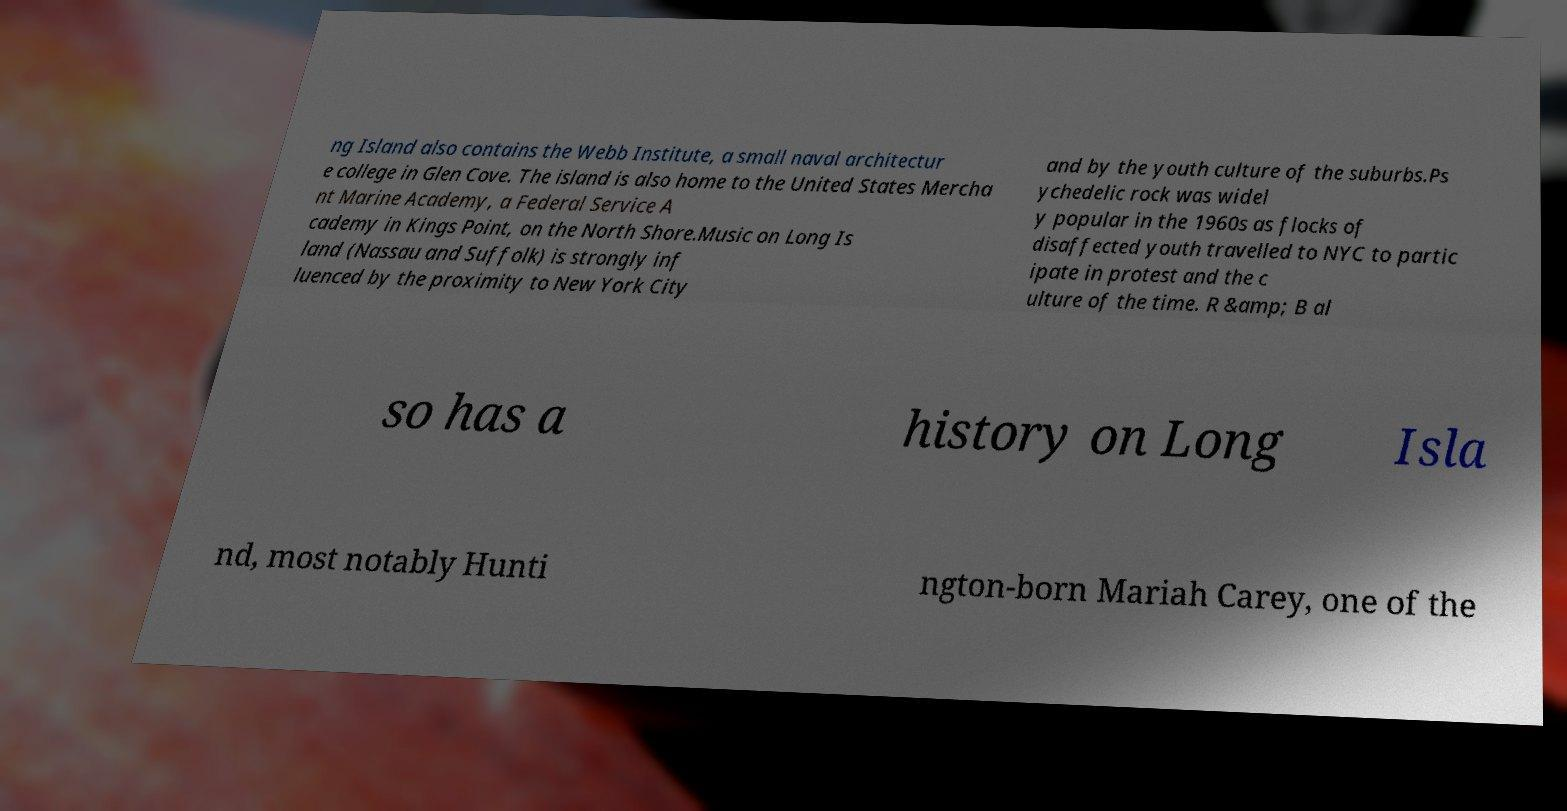Can you read and provide the text displayed in the image?This photo seems to have some interesting text. Can you extract and type it out for me? ng Island also contains the Webb Institute, a small naval architectur e college in Glen Cove. The island is also home to the United States Mercha nt Marine Academy, a Federal Service A cademy in Kings Point, on the North Shore.Music on Long Is land (Nassau and Suffolk) is strongly inf luenced by the proximity to New York City and by the youth culture of the suburbs.Ps ychedelic rock was widel y popular in the 1960s as flocks of disaffected youth travelled to NYC to partic ipate in protest and the c ulture of the time. R &amp; B al so has a history on Long Isla nd, most notably Hunti ngton-born Mariah Carey, one of the 